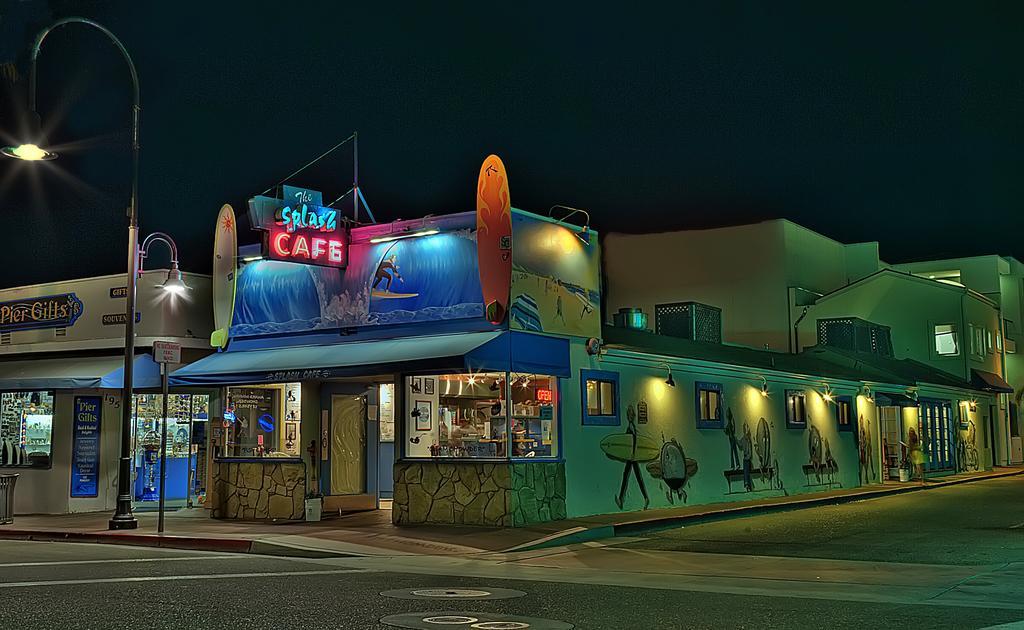In one or two sentences, can you explain what this image depicts? This image is taken outdoors. At the top of the image there is a sky. At the bottom of the image there is a road and there is a sidewalk. In the middle of the image there are a few houses and buildings with walls, windows, doors and roofs. There are many boards with text on them. There are a few paintings on the walls. On the left side of the image there is a street light on the sidewalk and there is a dustbin. 